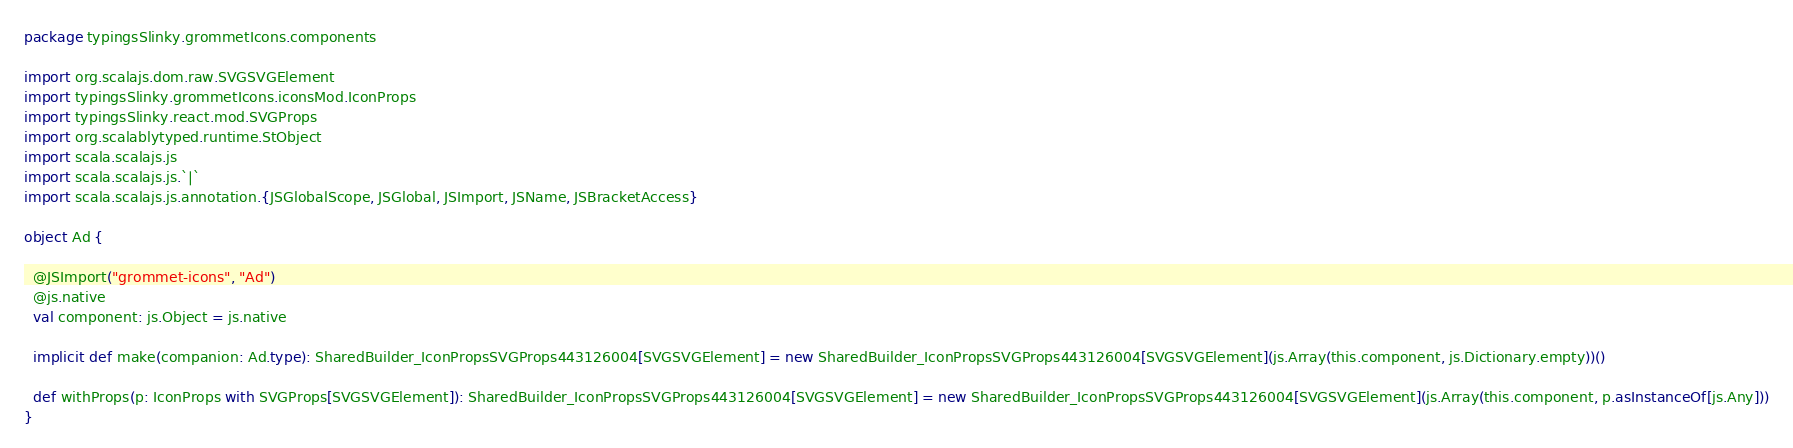<code> <loc_0><loc_0><loc_500><loc_500><_Scala_>package typingsSlinky.grommetIcons.components

import org.scalajs.dom.raw.SVGSVGElement
import typingsSlinky.grommetIcons.iconsMod.IconProps
import typingsSlinky.react.mod.SVGProps
import org.scalablytyped.runtime.StObject
import scala.scalajs.js
import scala.scalajs.js.`|`
import scala.scalajs.js.annotation.{JSGlobalScope, JSGlobal, JSImport, JSName, JSBracketAccess}

object Ad {
  
  @JSImport("grommet-icons", "Ad")
  @js.native
  val component: js.Object = js.native
  
  implicit def make(companion: Ad.type): SharedBuilder_IconPropsSVGProps443126004[SVGSVGElement] = new SharedBuilder_IconPropsSVGProps443126004[SVGSVGElement](js.Array(this.component, js.Dictionary.empty))()
  
  def withProps(p: IconProps with SVGProps[SVGSVGElement]): SharedBuilder_IconPropsSVGProps443126004[SVGSVGElement] = new SharedBuilder_IconPropsSVGProps443126004[SVGSVGElement](js.Array(this.component, p.asInstanceOf[js.Any]))
}
</code> 